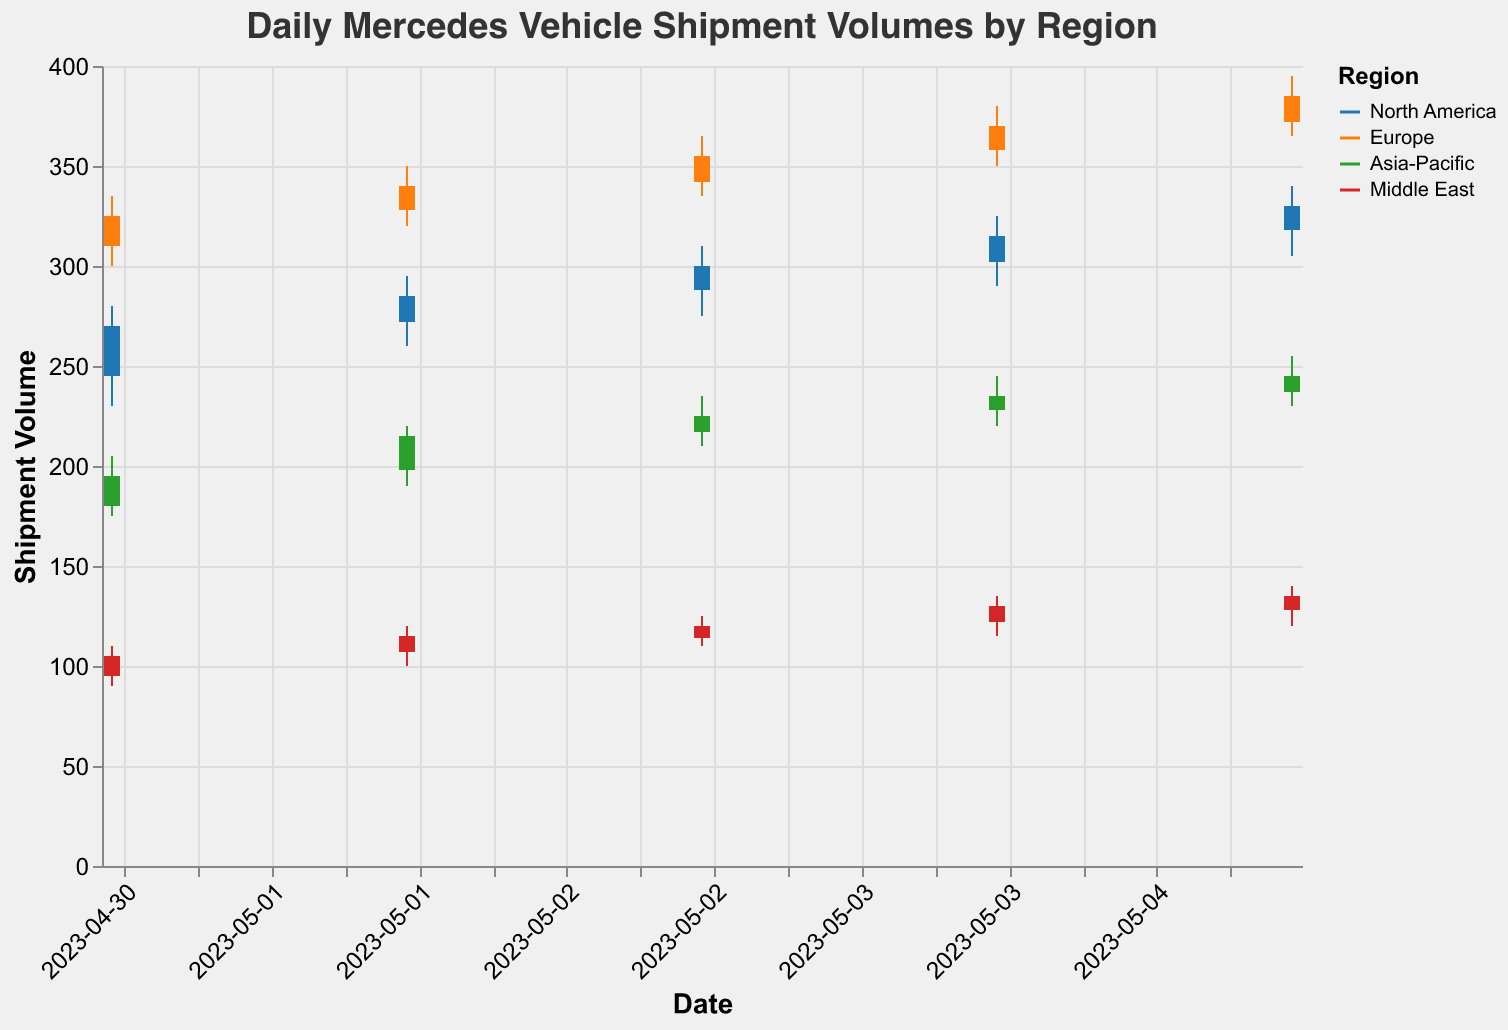What's the highest shipment volume recorded for the Europe region? The highest shipment volume for the Europe region can be determined by referring to the 'High' values specific to the Europe region. On 2023-05-05, Europe has the highest recorded volume of 395.
Answer: 395 Which region showed the most significant increase in shipment volume from 2023-05-01 to 2023-05-05? To find out the most significant increase, we calculate the difference between 'Close' on 2023-05-05 and 2023-05-01 for each region. For North America, it's 330 - 270 = 60. For Europe, it's 385 - 325 = 60. For Asia-Pacific, it's 245 - 195 = 50. For Middle East, it's 135 - 105 = 30. Both North America and Europe showed an increase of 60 units.
Answer: North America and Europe What was the opening shipment volume for the Asia-Pacific region on 2023-05-03? The opening shipment volume for the Asia-Pacific region on 2023-05-03 is listed under the 'Open' field for that date and region, which is 217.
Answer: 217 Which region had the lowest shipment volume on any given date and what was the value? The lowest shipment volume can be found by looking at the 'Low' field across all regions and dates. For 2023-05-01, the Middle East had the lowest volume at 90.
Answer: Middle East, 90 On which date did North America close at its highest value within the given range? To determine this, refer to the 'Close' values for North America. On 2023-05-05, North America closed at its highest value of 330.
Answer: 2023-05-05 How did Europe’s shipment volumes change from 2023-05-02 to 2023-05-03? Europe’s opening volume on 2023-05-02 was 328 and it closed at 340. On 2023-05-03, Europe opened at 342 and closed at 355. This shows an increase in the opening volume by 342 - 328 = 14 and an increase in the closing volume by 355 - 340 = 15.
Answer: Increased by 14 (open), Increased by 15 (close) What’s the difference between the highest and lowest shipment volumes in North America on 2023-05-04? For North America on 2023-05-04, the highest volume is 325 and the lowest is 290. The difference is 325 - 290 = 35.
Answer: 35 Which region had the smallest range (High - Low) of shipment volumes on 2023-05-05? Calculate the range for each region on 2023-05-05. North America: 340 - 305 = 35. Europe: 395 - 365 = 30. Asia-Pacific: 255 - 230 = 25. Middle East: 140 - 120 = 20. The Middle East had the smallest range of 20 units.
Answer: Middle East 